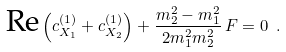<formula> <loc_0><loc_0><loc_500><loc_500>\text {Re} \left ( c _ { X _ { 1 } } ^ { ( 1 ) } + c _ { X _ { 2 } } ^ { ( 1 ) } \right ) + \frac { m _ { 2 } ^ { 2 } - m _ { 1 } ^ { 2 } } { 2 m _ { 1 } ^ { 2 } m _ { 2 } ^ { 2 } } \, F = 0 \ .</formula> 